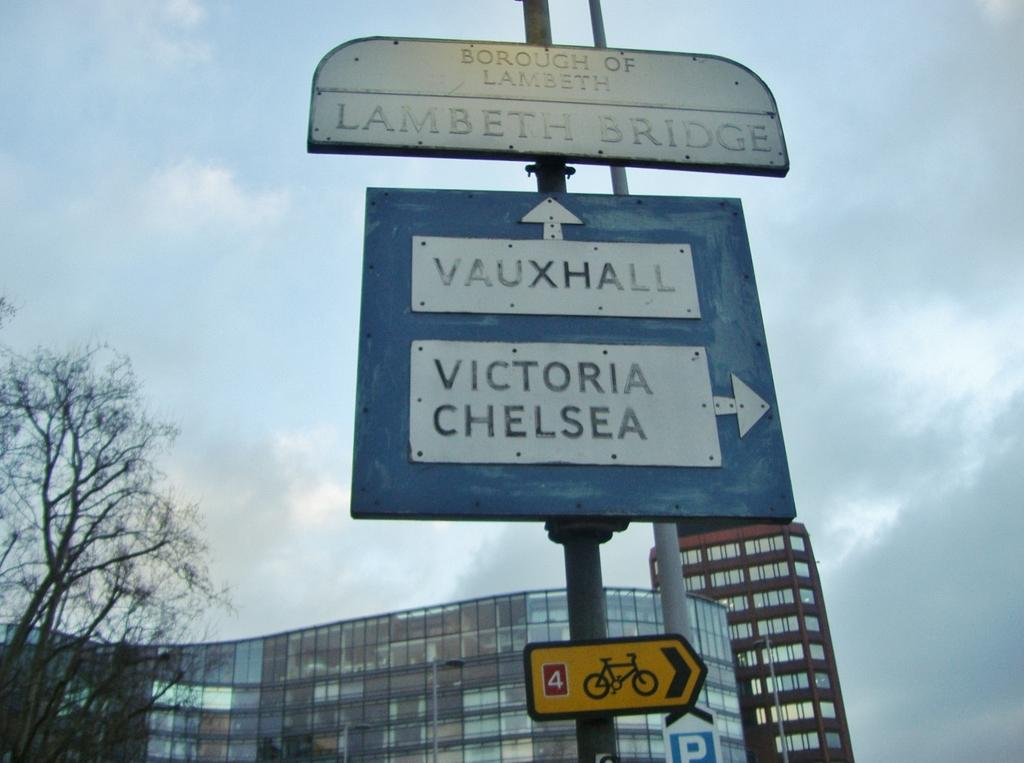<image>
Create a compact narrative representing the image presented. The sign gives people guidance on which way to Vauxhall and Victoria Chelsea. 